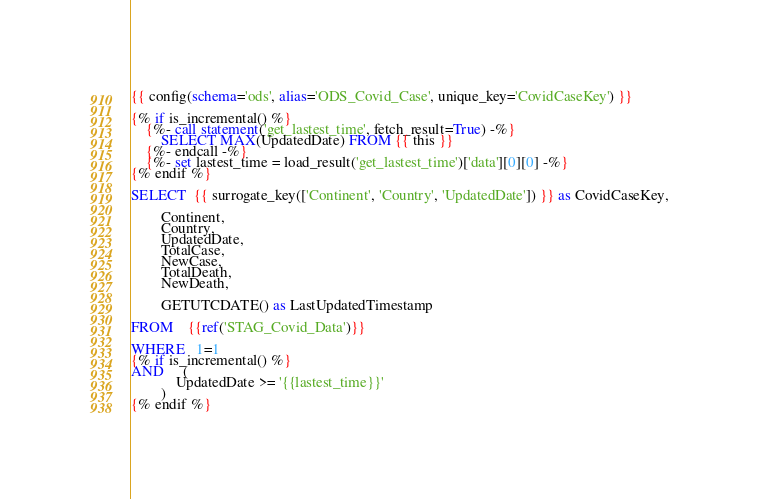<code> <loc_0><loc_0><loc_500><loc_500><_SQL_>{{ config(schema='ods', alias='ODS_Covid_Case', unique_key='CovidCaseKey') }}

{% if is_incremental() %}
    {%- call statement('get_lastest_time', fetch_result=True) -%}
        SELECT MAX(UpdatedDate) FROM {{ this }}
    {%- endcall -%}
    {%- set lastest_time = load_result('get_lastest_time')['data'][0][0] -%}
{% endif %}

SELECT  {{ surrogate_key(['Continent', 'Country', 'UpdatedDate']) }} as CovidCaseKey,
        
        Continent,
        Country,
        UpdatedDate,
        TotalCase,
        NewCase,
        TotalDeath,
        NewDeath,

        GETUTCDATE() as LastUpdatedTimestamp

FROM    {{ref('STAG_Covid_Data')}}

WHERE   1=1
{% if is_incremental() %}
AND     (
            UpdatedDate >= '{{lastest_time}}'
        )
{% endif %}</code> 